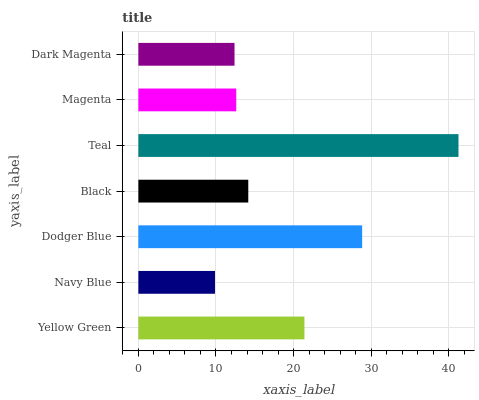Is Navy Blue the minimum?
Answer yes or no. Yes. Is Teal the maximum?
Answer yes or no. Yes. Is Dodger Blue the minimum?
Answer yes or no. No. Is Dodger Blue the maximum?
Answer yes or no. No. Is Dodger Blue greater than Navy Blue?
Answer yes or no. Yes. Is Navy Blue less than Dodger Blue?
Answer yes or no. Yes. Is Navy Blue greater than Dodger Blue?
Answer yes or no. No. Is Dodger Blue less than Navy Blue?
Answer yes or no. No. Is Black the high median?
Answer yes or no. Yes. Is Black the low median?
Answer yes or no. Yes. Is Navy Blue the high median?
Answer yes or no. No. Is Navy Blue the low median?
Answer yes or no. No. 